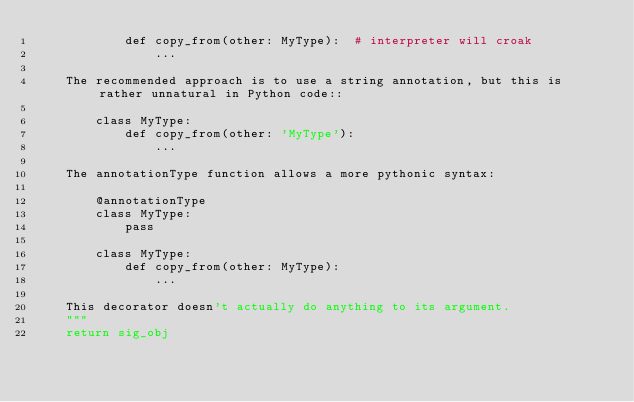Convert code to text. <code><loc_0><loc_0><loc_500><loc_500><_Python_>            def copy_from(other: MyType):  # interpreter will croak
                ...

    The recommended approach is to use a string annotation, but this is rather unnatural in Python code::

        class MyType:
            def copy_from(other: 'MyType'):
                ...

    The annotationType function allows a more pythonic syntax:

        @annotationType
        class MyType:
            pass

        class MyType:
            def copy_from(other: MyType):
                ...

    This decorator doesn't actually do anything to its argument.
    """
    return sig_obj
</code> 